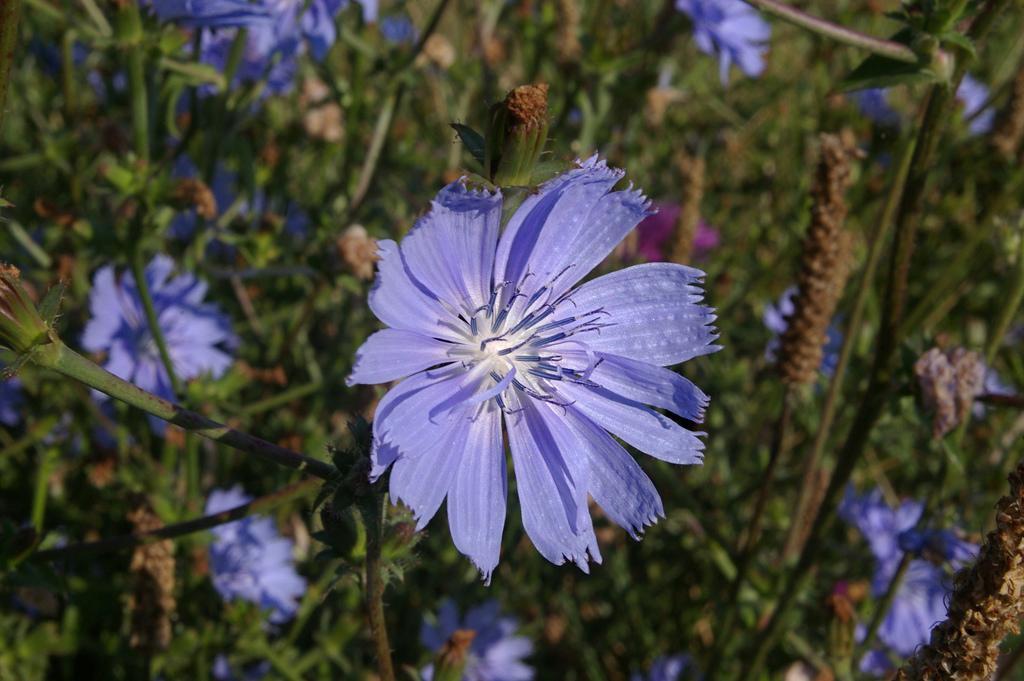How would you summarize this image in a sentence or two? In this image I can see few flowers in purple and pink color and few plants in green color. 